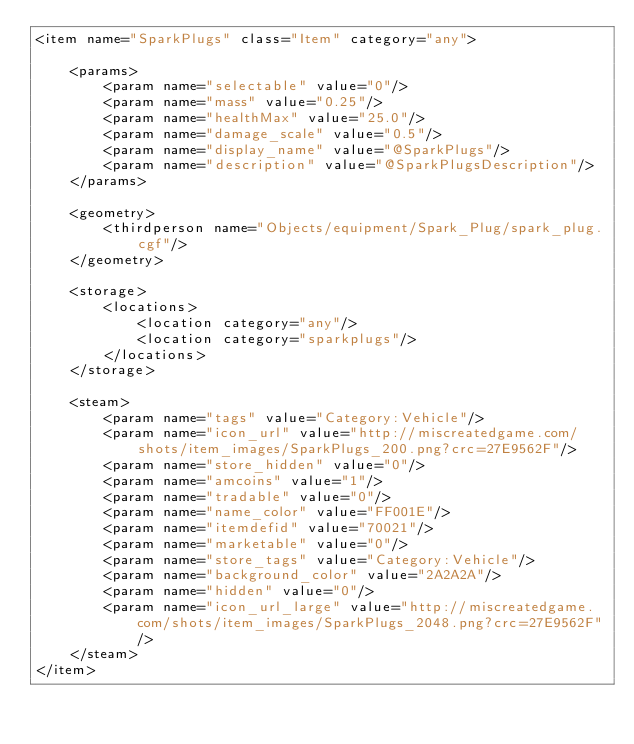Convert code to text. <code><loc_0><loc_0><loc_500><loc_500><_XML_><item name="SparkPlugs" class="Item" category="any">

	<params>
		<param name="selectable" value="0"/>
		<param name="mass" value="0.25"/>
		<param name="healthMax" value="25.0"/>
		<param name="damage_scale" value="0.5"/>
		<param name="display_name" value="@SparkPlugs"/>
		<param name="description" value="@SparkPlugsDescription"/>
	</params>

	<geometry>
		<thirdperson name="Objects/equipment/Spark_Plug/spark_plug.cgf"/>
	</geometry>

	<storage>
		<locations>
			<location category="any"/>
			<location category="sparkplugs"/>
		</locations>
	</storage>

	<steam>
		<param name="tags" value="Category:Vehicle"/>
		<param name="icon_url" value="http://miscreatedgame.com/shots/item_images/SparkPlugs_200.png?crc=27E9562F"/>
		<param name="store_hidden" value="0"/>
		<param name="amcoins" value="1"/>
		<param name="tradable" value="0"/>
		<param name="name_color" value="FF001E"/>
		<param name="itemdefid" value="70021"/>
		<param name="marketable" value="0"/>
		<param name="store_tags" value="Category:Vehicle"/>
		<param name="background_color" value="2A2A2A"/>
		<param name="hidden" value="0"/>
		<param name="icon_url_large" value="http://miscreatedgame.com/shots/item_images/SparkPlugs_2048.png?crc=27E9562F"/>
	</steam>
</item></code> 